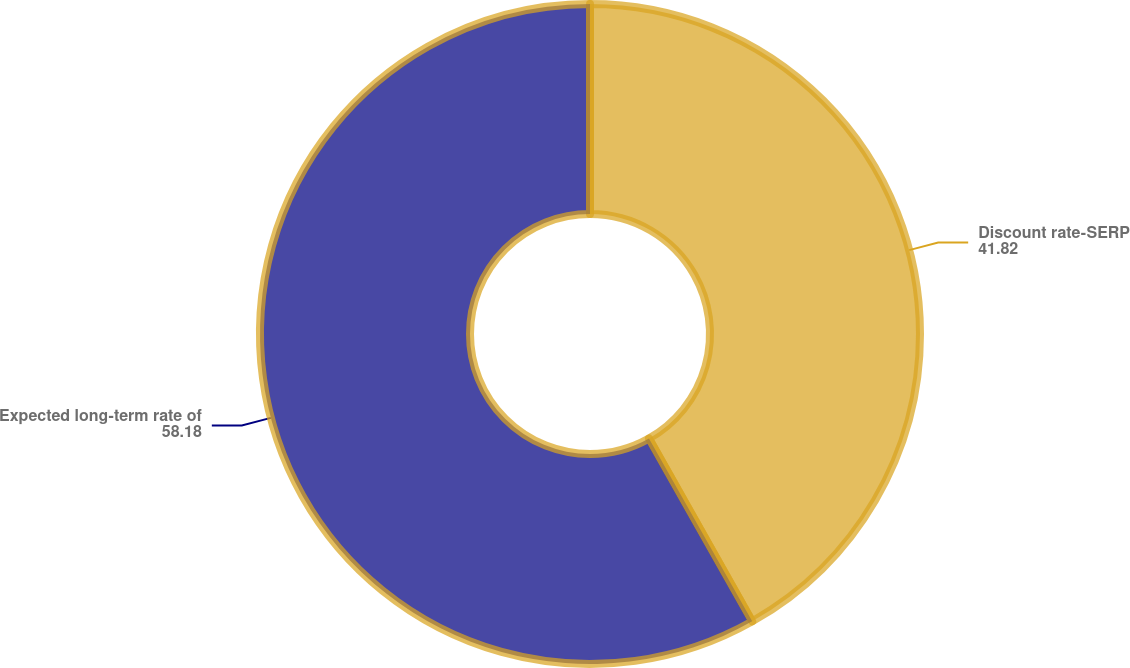<chart> <loc_0><loc_0><loc_500><loc_500><pie_chart><fcel>Discount rate-SERP<fcel>Expected long-term rate of<nl><fcel>41.82%<fcel>58.18%<nl></chart> 